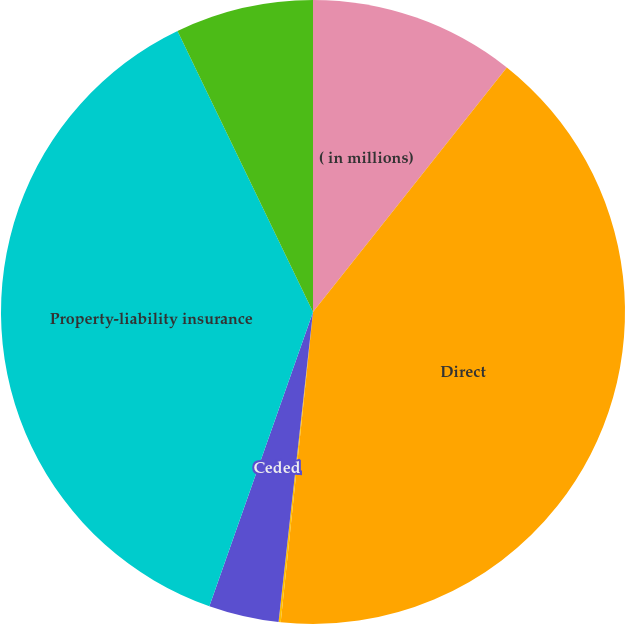Convert chart. <chart><loc_0><loc_0><loc_500><loc_500><pie_chart><fcel>( in millions)<fcel>Direct<fcel>Assumed<fcel>Ceded<fcel>Property-liability insurance<fcel>Life and annuity premiums and<nl><fcel>10.67%<fcel>40.98%<fcel>0.11%<fcel>3.63%<fcel>37.46%<fcel>7.15%<nl></chart> 